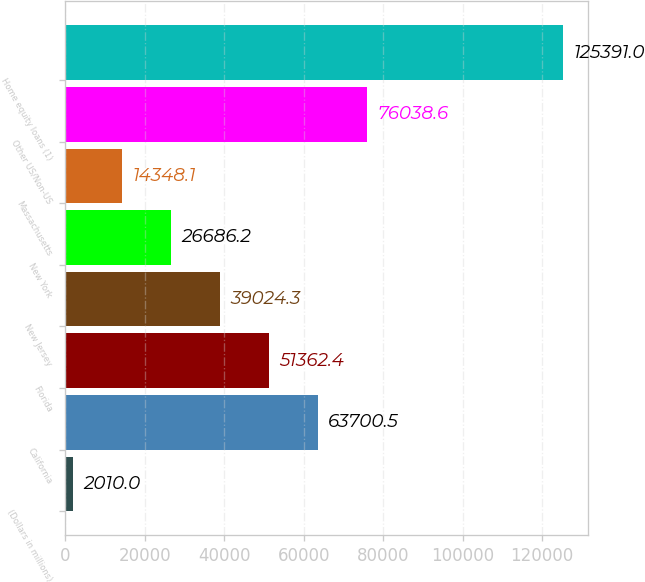<chart> <loc_0><loc_0><loc_500><loc_500><bar_chart><fcel>(Dollars in millions)<fcel>California<fcel>Florida<fcel>New Jersey<fcel>New York<fcel>Massachusetts<fcel>Other US/Non-US<fcel>Home equity loans (1)<nl><fcel>2010<fcel>63700.5<fcel>51362.4<fcel>39024.3<fcel>26686.2<fcel>14348.1<fcel>76038.6<fcel>125391<nl></chart> 